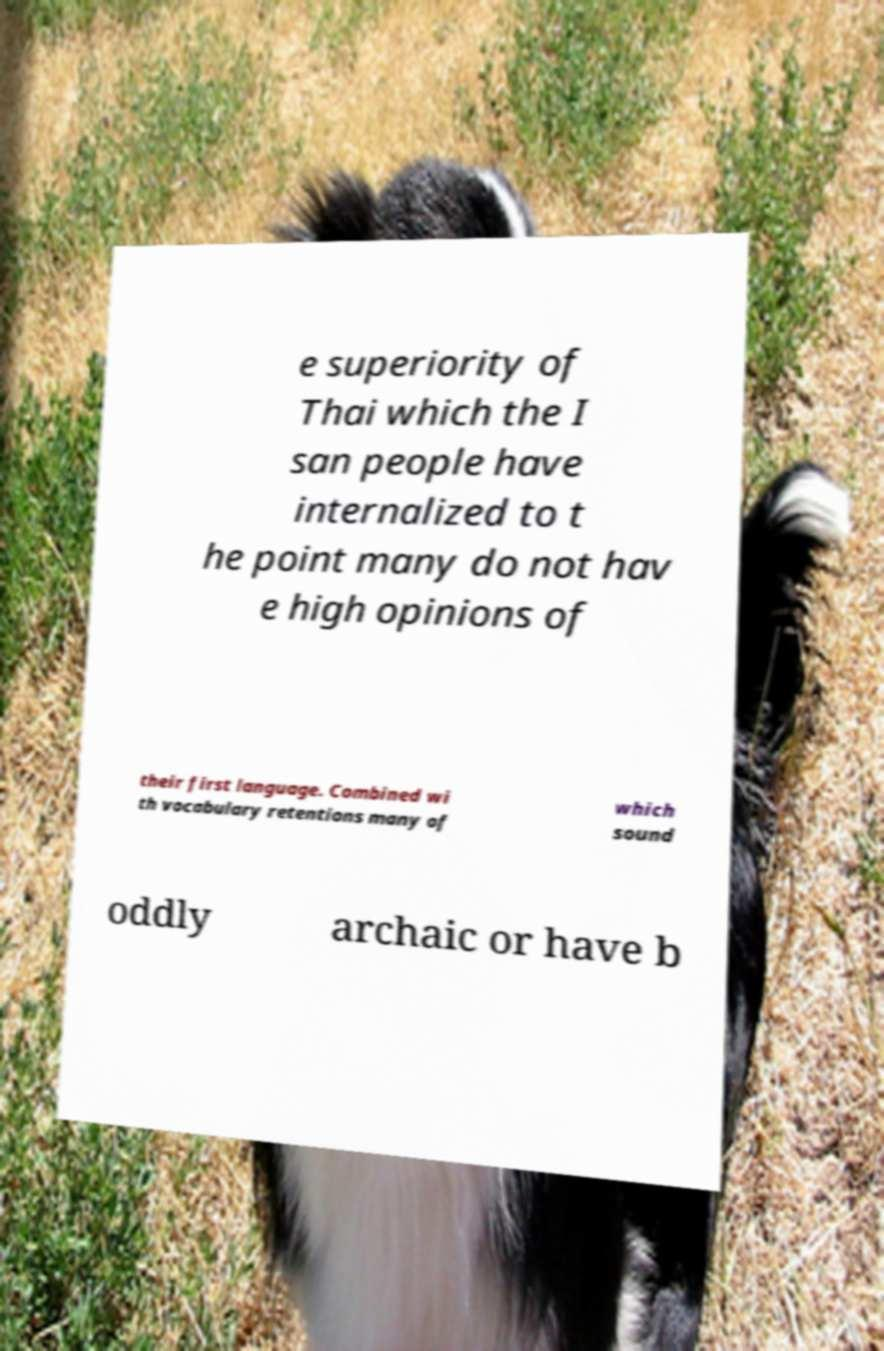Could you extract and type out the text from this image? e superiority of Thai which the I san people have internalized to t he point many do not hav e high opinions of their first language. Combined wi th vocabulary retentions many of which sound oddly archaic or have b 